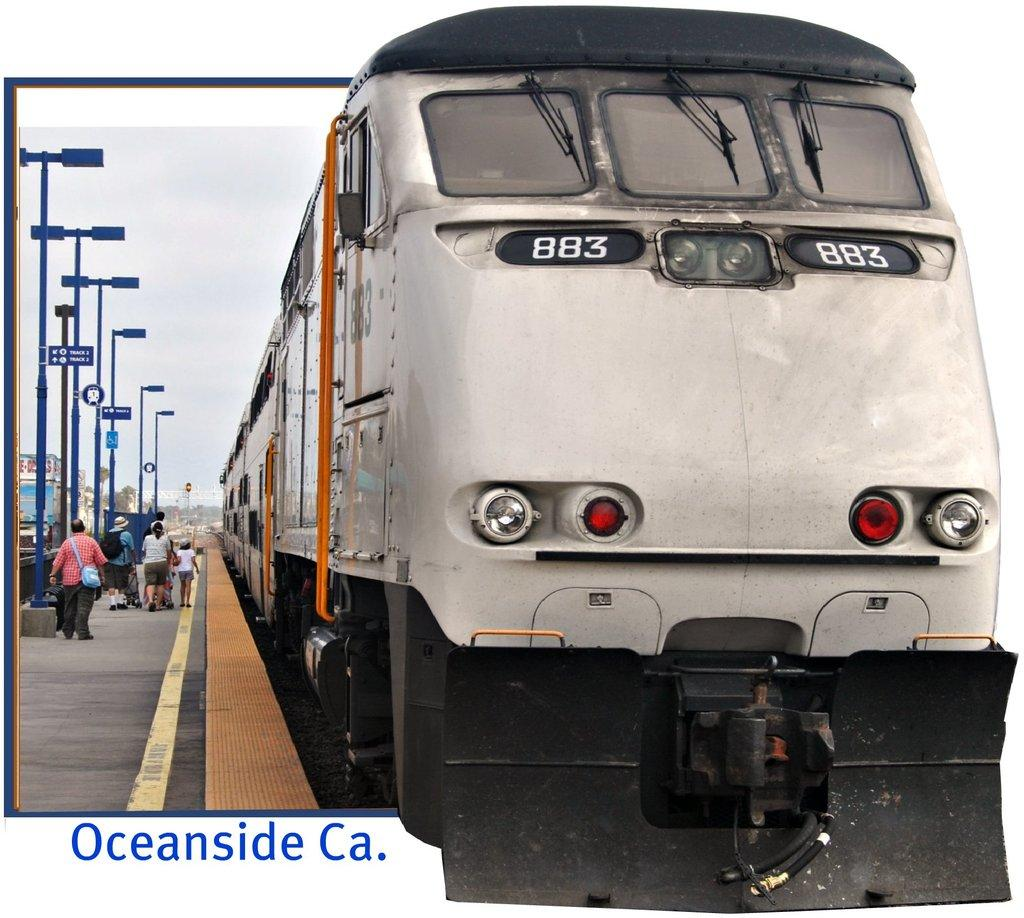<image>
Summarize the visual content of the image. A train pulls into station in Oceanside California as people prepare to board. 